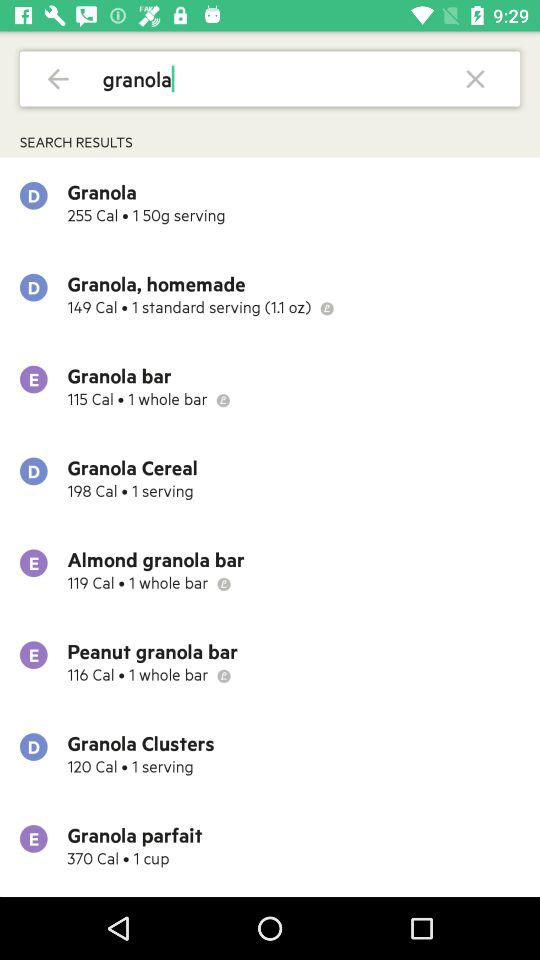What is the count of "Almond granola bar"? The count is 1. 